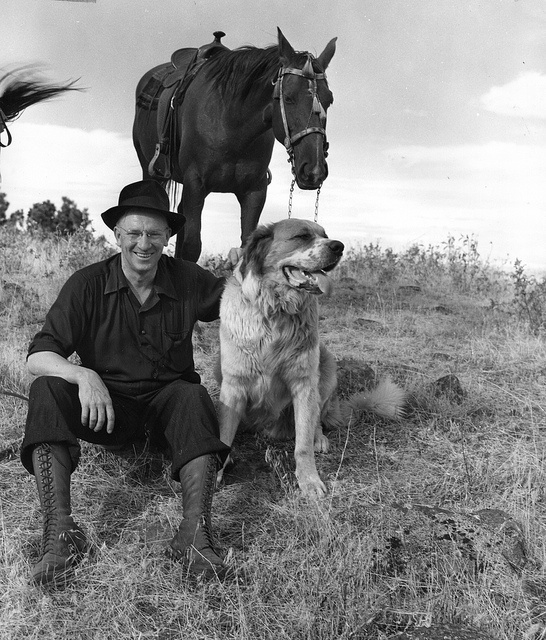Describe the objects in this image and their specific colors. I can see people in lightgray, black, gray, and darkgray tones, horse in lightgray, black, gray, and darkgray tones, and dog in lightgray, gray, darkgray, and black tones in this image. 